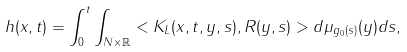<formula> <loc_0><loc_0><loc_500><loc_500>h ( x , t ) = \int _ { 0 } ^ { t } \int _ { N \times \mathbb { R } } < K _ { L } ( x , t , y , s ) , R ( y , s ) > d \mu _ { g _ { 0 } ( s ) } ( y ) d s ,</formula> 